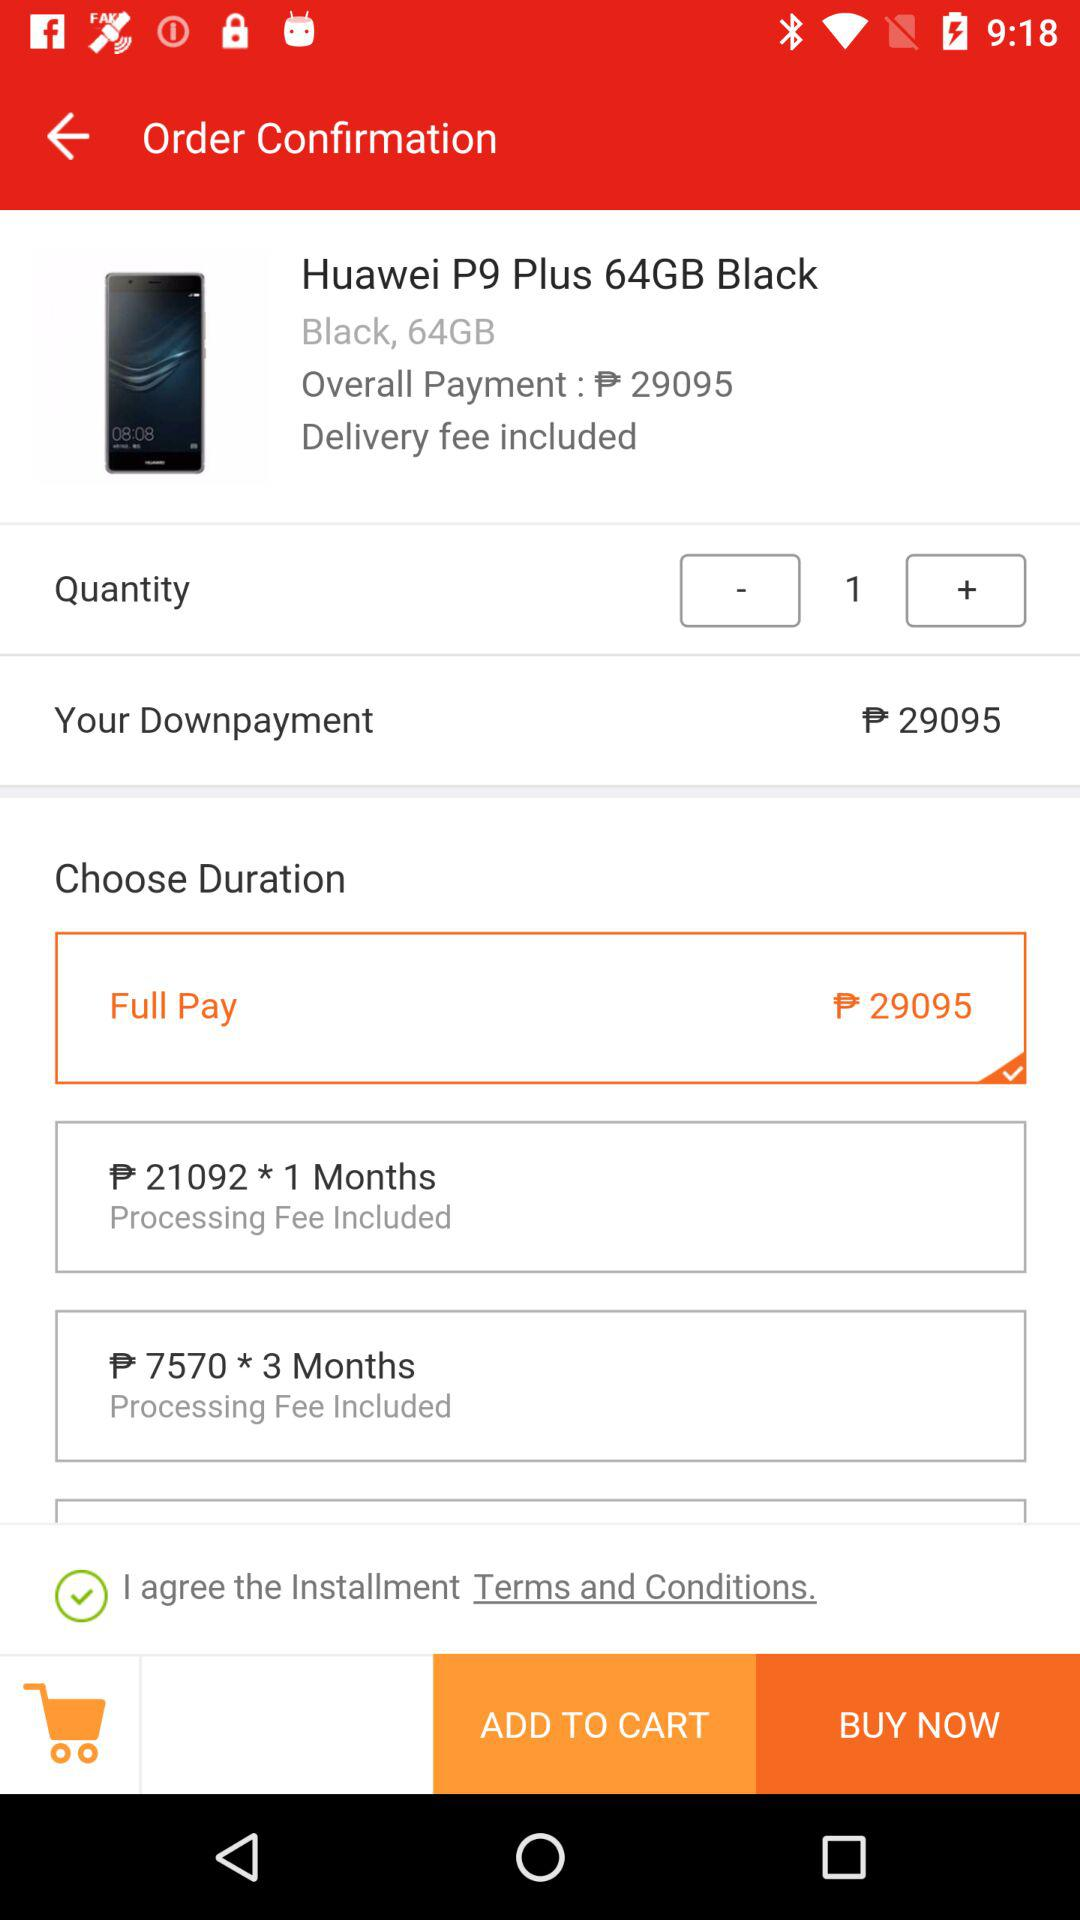What is the product name? The product name is "Huawei P9 Plus 64GB Black". 